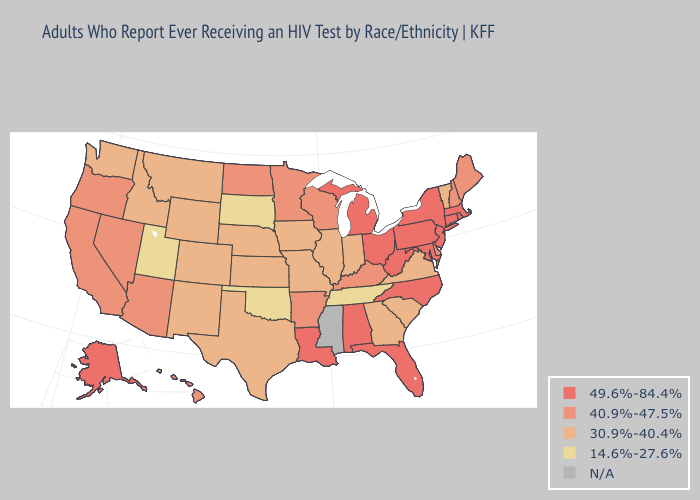Which states hav the highest value in the West?
Give a very brief answer. Alaska. Among the states that border Arkansas , does Oklahoma have the highest value?
Quick response, please. No. Which states have the highest value in the USA?
Answer briefly. Alabama, Alaska, Connecticut, Florida, Louisiana, Maryland, Massachusetts, Michigan, New Jersey, New York, North Carolina, Ohio, Pennsylvania, Rhode Island, West Virginia. Among the states that border Mississippi , which have the lowest value?
Give a very brief answer. Tennessee. Among the states that border New York , which have the lowest value?
Give a very brief answer. Vermont. Among the states that border New Mexico , which have the lowest value?
Write a very short answer. Oklahoma, Utah. What is the value of Kentucky?
Give a very brief answer. 40.9%-47.5%. Does the map have missing data?
Concise answer only. Yes. What is the lowest value in the South?
Short answer required. 14.6%-27.6%. What is the value of Washington?
Quick response, please. 30.9%-40.4%. Among the states that border Georgia , which have the lowest value?
Write a very short answer. Tennessee. Name the states that have a value in the range 49.6%-84.4%?
Keep it brief. Alabama, Alaska, Connecticut, Florida, Louisiana, Maryland, Massachusetts, Michigan, New Jersey, New York, North Carolina, Ohio, Pennsylvania, Rhode Island, West Virginia. Name the states that have a value in the range 49.6%-84.4%?
Give a very brief answer. Alabama, Alaska, Connecticut, Florida, Louisiana, Maryland, Massachusetts, Michigan, New Jersey, New York, North Carolina, Ohio, Pennsylvania, Rhode Island, West Virginia. 